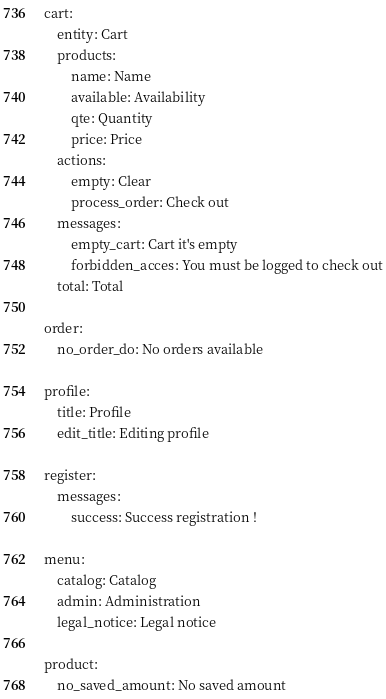<code> <loc_0><loc_0><loc_500><loc_500><_YAML_>cart:
    entity: Cart
    products:
        name: Name
        available: Availability
        qte: Quantity
        price: Price
    actions:
        empty: Clear
        process_order: Check out
    messages:
        empty_cart: Cart it's empty
        forbidden_acces: You must be logged to check out
    total: Total

order:
    no_order_do: No orders available

profile:
    title: Profile
    edit_title: Editing profile

register:
    messages:
        success: Success registration !

menu:
    catalog: Catalog
    admin: Administration
    legal_notice: Legal notice

product:
    no_saved_amount: No saved amount</code> 